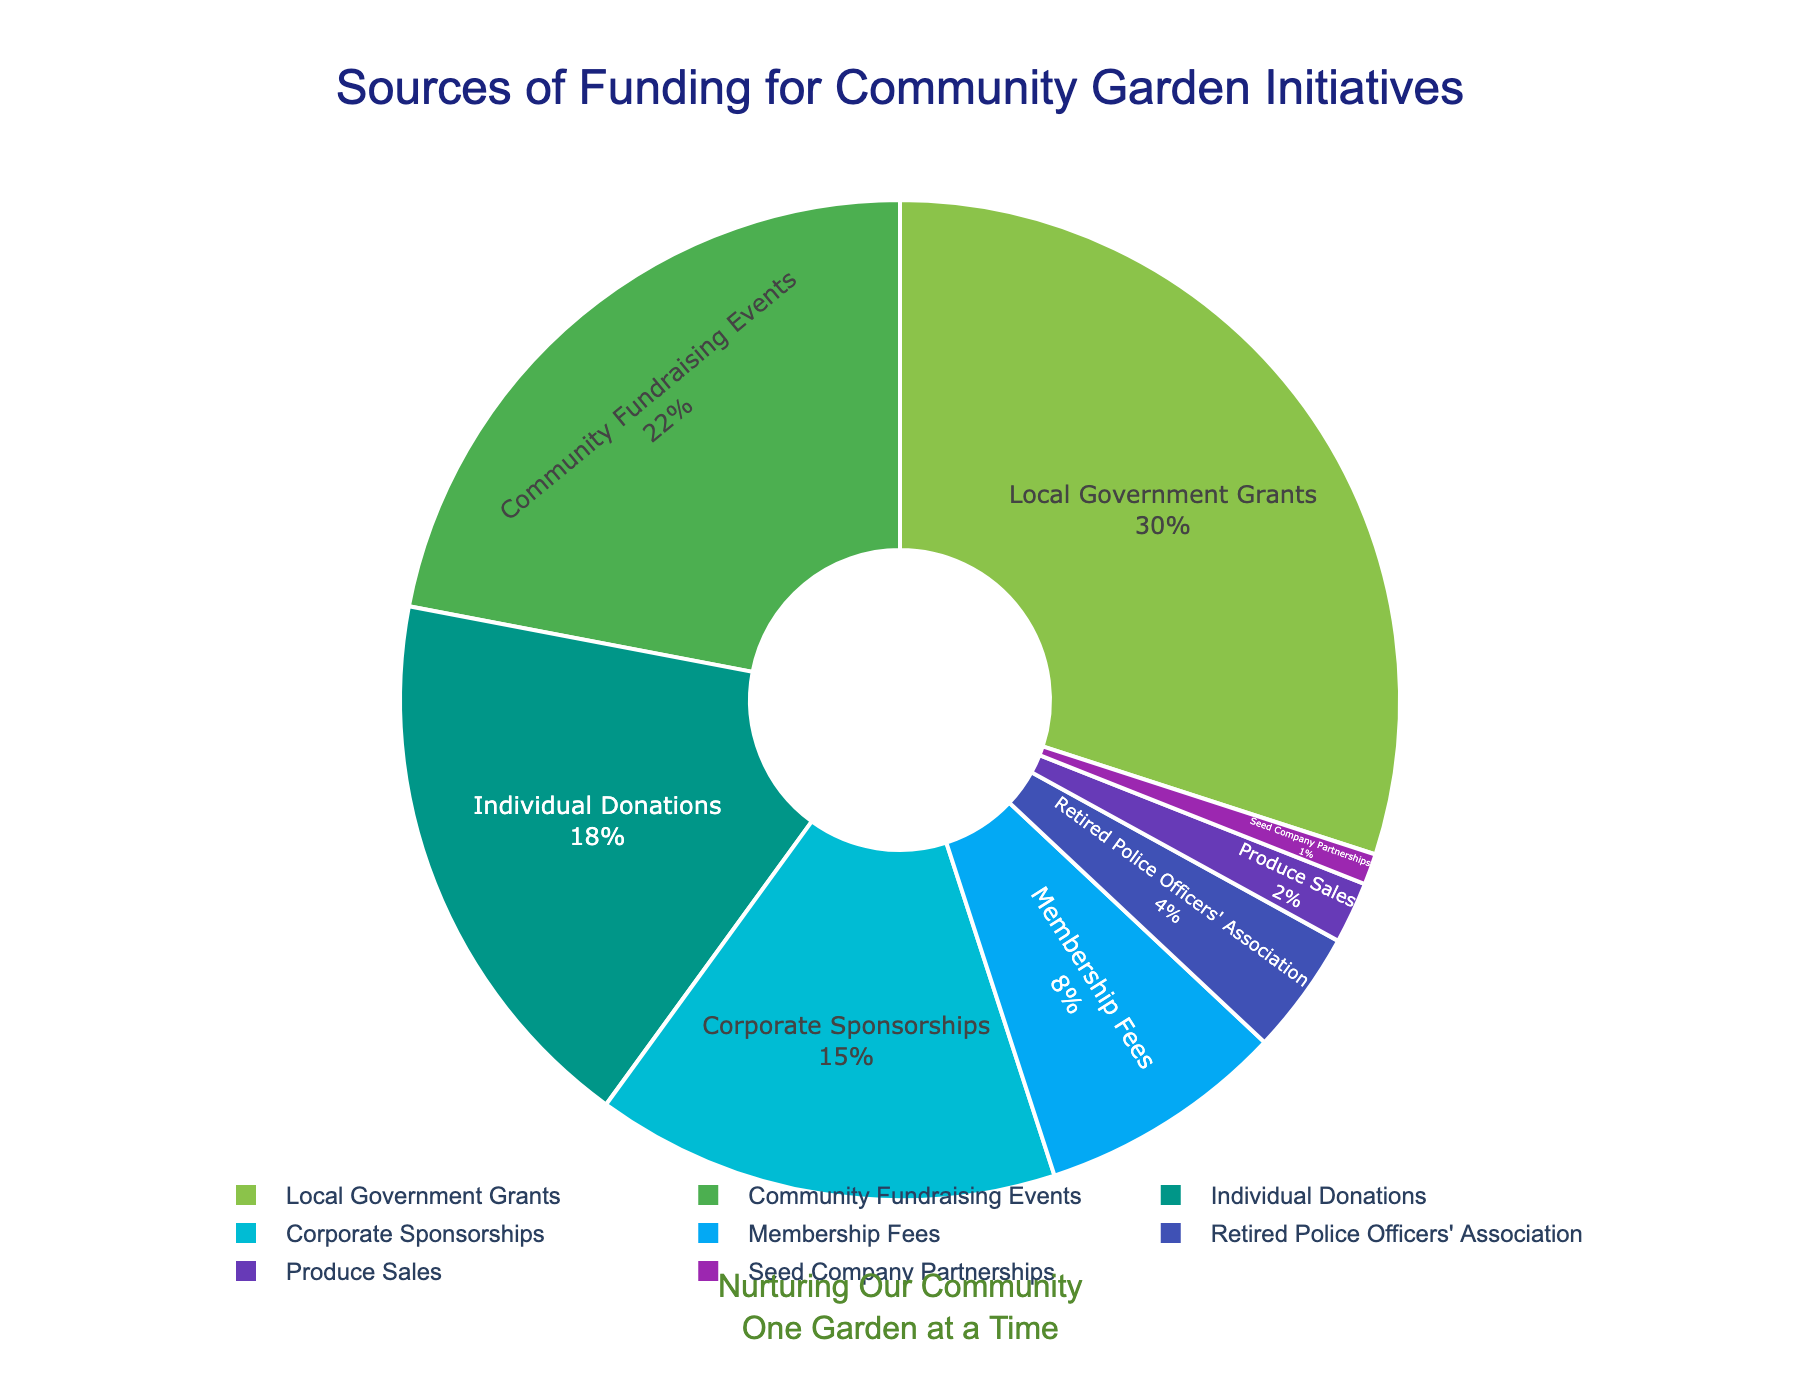what percentage of funding comes from community fundraising events? By inspecting the pie chart, we look for the segment labeled "Community Fundraising Events" and note its percentage.
Answer: 22% which funding source provides the most significant portion of the total funding? We examine the pie chart for the largest segment. The segment labeled "Local Government Grants" appears to be the largest.
Answer: Local Government Grants which two funding sources combined contribute more than 50% of the total funding? We add the percentages of the segments to find combinations that exceed 50%. "Local Government Grants" (30%) combined with "Community Fundraising Events" (22%) gives us 52%.
Answer: Local Government Grants and Community Fundraising Events how does the percentage of funds from individual donations compare to corporate sponsorships? We compare the segment labeled "Individual Donations" (18%) with the one labeled "Corporate Sponsorships" (15%).
Answer: Individual Donations are higher than Corporate Sponsorships are the contributions from produce sales and seed company partnerships combined greater than those from the retired police officers' association? We sum the percentages for "Produce Sales" (2%) and "Seed Company Partnerships" (1%), resulting in 3%. Then we compare this to the "Retired Police Officers' Association" percentage (4%). 3% is less than 4%.
Answer: No what is the total percentage of funding sources that contribute less than 10% each? We add the percentages of "Membership Fees" (8%), "Retired Police Officers' Association" (4%), "Produce Sales" (2%), and "Seed Company Partnerships" (1%). 8% + 4% + 2% + 1% = 15%.
Answer: 15% which segment in the pie chart is colored blue? By visually inspecting the colors of the segments in the pie chart, the segment representing "Corporate Sponsorships" is blue.
Answer: Corporate Sponsorships what percentage of funding comes from sources associated specifically with retired professionals or organizations? We find the segment labeled "Retired Police Officers' Association" which contributes 4%.
Answer: 4% if community fundraising events and individual donations were merged into a single category, what would the combined percentage be? By adding the percentages of both segments: 22% (Community Fundraising Events) + 18% (Individual Donations) = 40%.
Answer: 40% which funding source comes in fifth place in terms of percentage contribution? We rank the funding sources by their percentage contributions. "Membership Fees" at 8% is the fifth highest contribution.
Answer: Membership Fees 